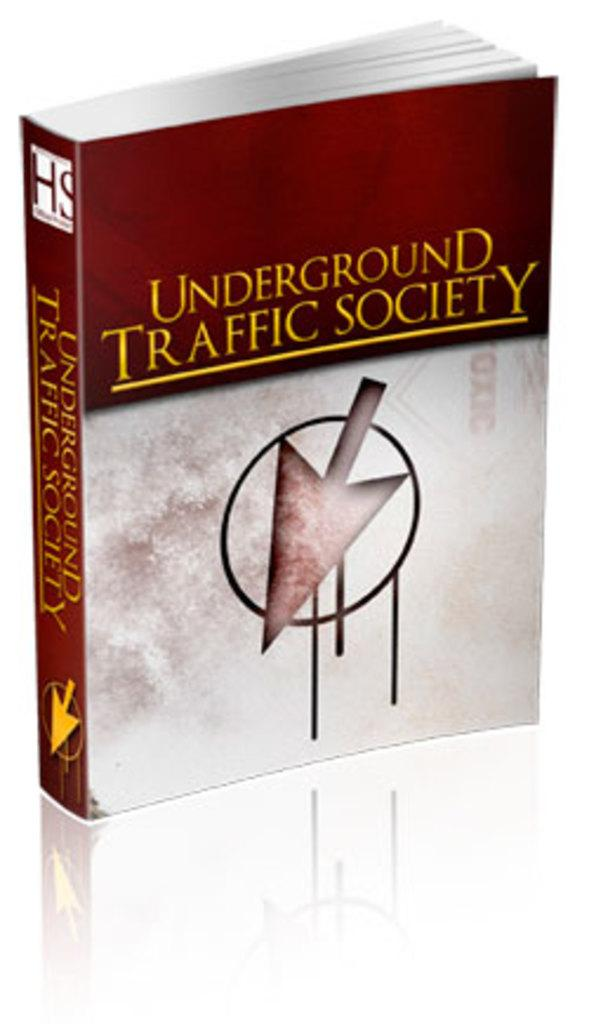Provide a one-sentence caption for the provided image. A book sitting upright titled Underground Traffic Society. 